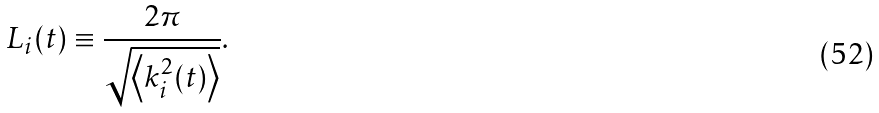<formula> <loc_0><loc_0><loc_500><loc_500>L _ { i } ( t ) \equiv \frac { 2 \pi } { \sqrt { \left < k ^ { 2 } _ { i } ( t ) \right > } } .</formula> 